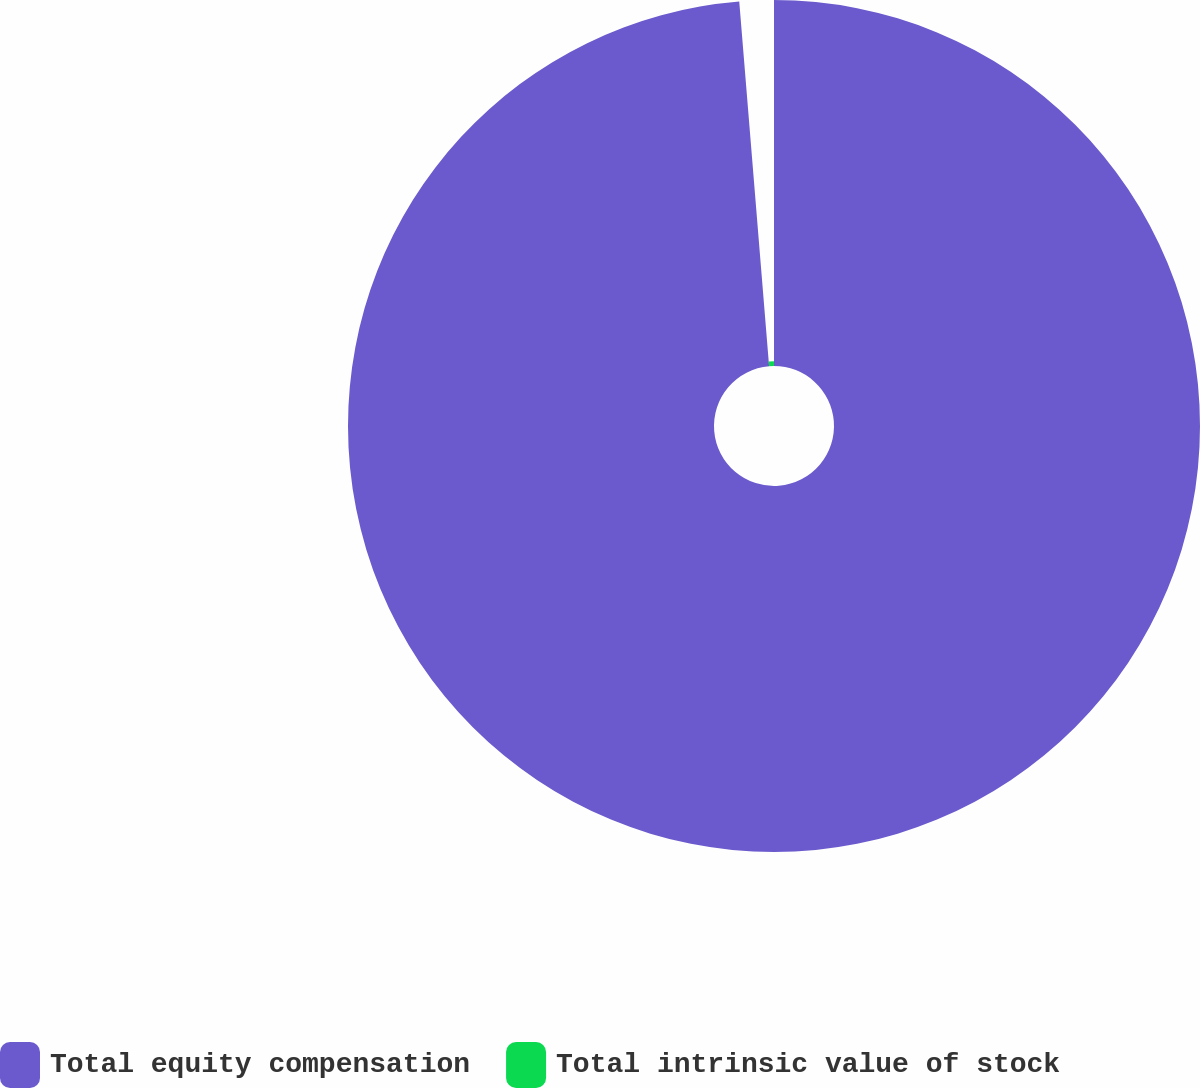Convert chart. <chart><loc_0><loc_0><loc_500><loc_500><pie_chart><fcel>Total equity compensation<fcel>Total intrinsic value of stock<nl><fcel>98.7%<fcel>1.3%<nl></chart> 